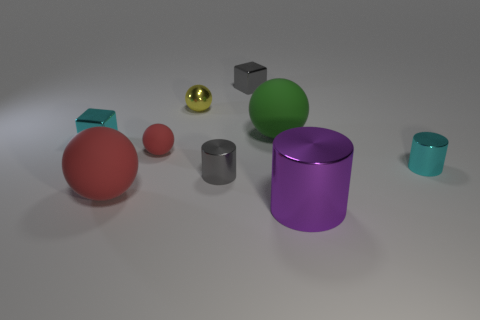Add 1 small gray blocks. How many objects exist? 10 Subtract all cylinders. How many objects are left? 6 Add 5 tiny matte balls. How many tiny matte balls are left? 6 Add 3 green metallic spheres. How many green metallic spheres exist? 3 Subtract 0 yellow blocks. How many objects are left? 9 Subtract all red spheres. Subtract all small red rubber things. How many objects are left? 6 